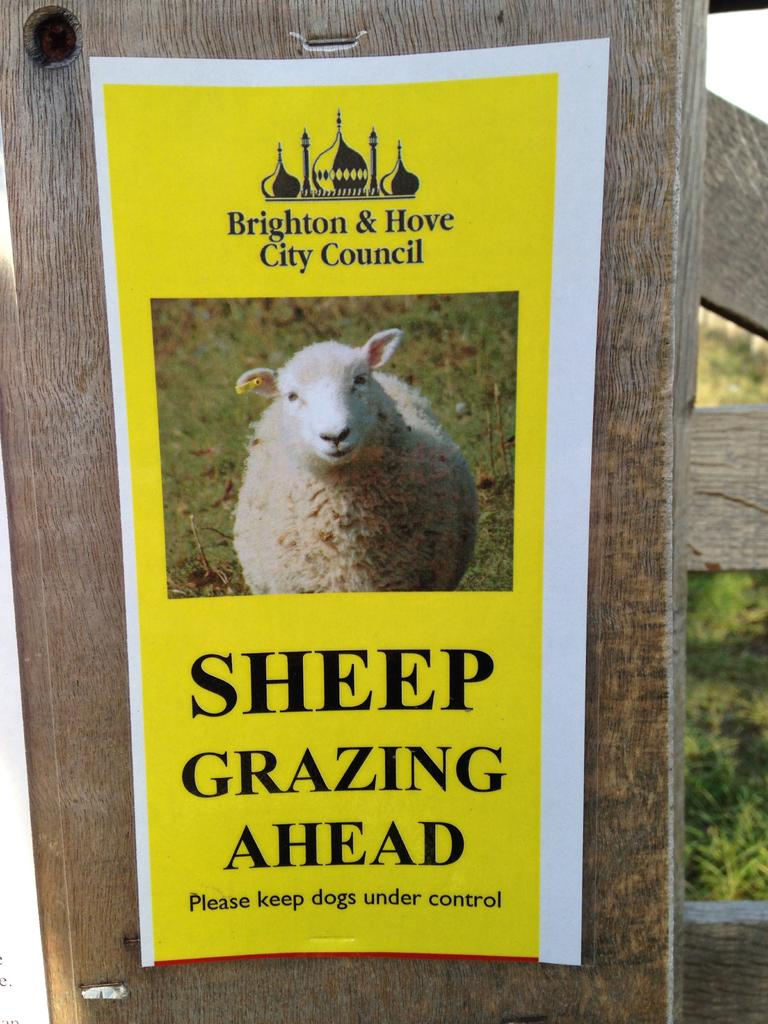What is the main object in the image? There is a wooden board in the image. the image. What is on the wooden board? There is a poster on the wooden board. What can be found on the poster? The poster contains text and features an image of sheep. What is visible in the background of the image? There are wooden boards and plants in the background of the image. What type of veil can be seen covering the sheep in the image? There is no veil covering the sheep in the image; the poster simply features an image of sheep. Can you hear a whistle in the image? There is no sound in the image, so it is not possible to hear a whistle. 